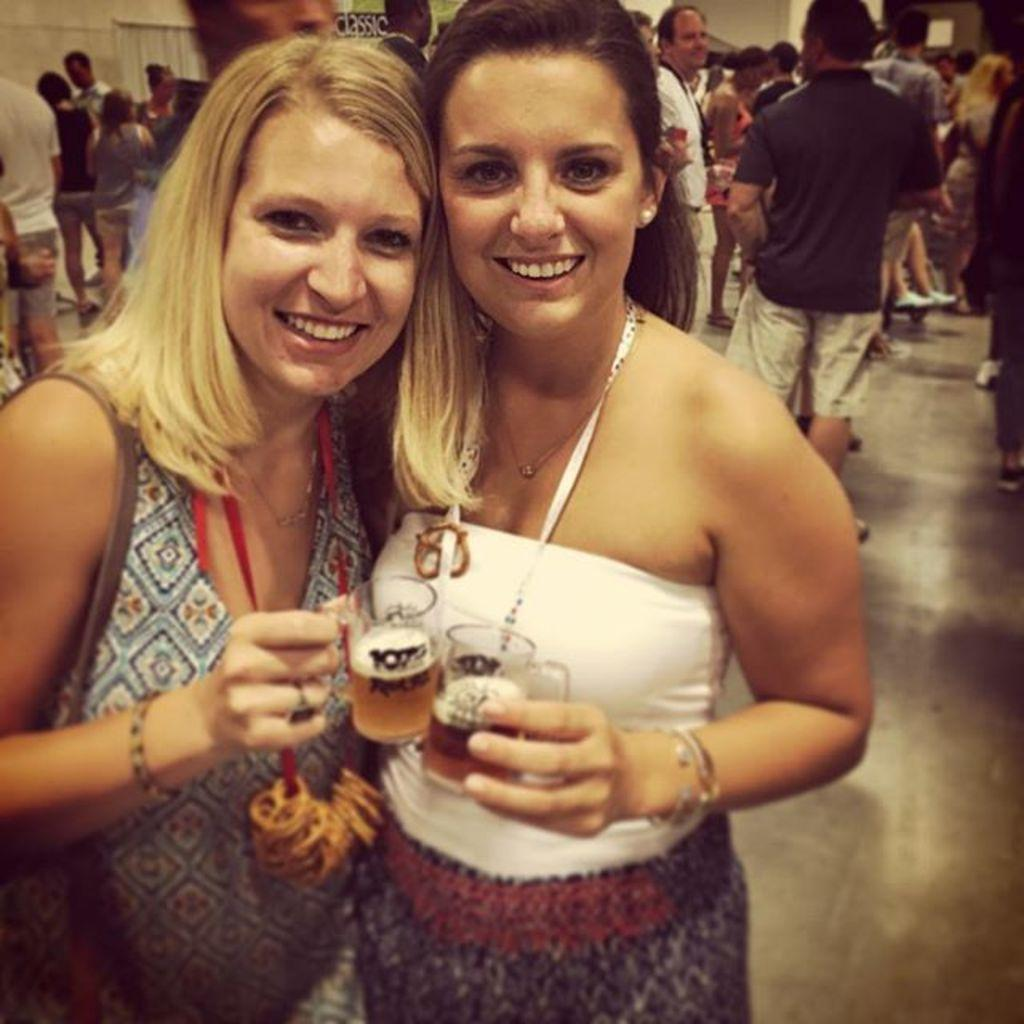How many women are in the image? There are two women in the image. What are the women holding in their hands? The women are holding drinks in their hands. Can you describe the setting of the image based on the visible background? There are many people visible in the background of the image, suggesting a crowded or social setting. What historical discovery can be seen in the image? There is no historical discovery present in the image; it features two women holding drinks. What type of root is visible in the image? There is no root visible in the image. 